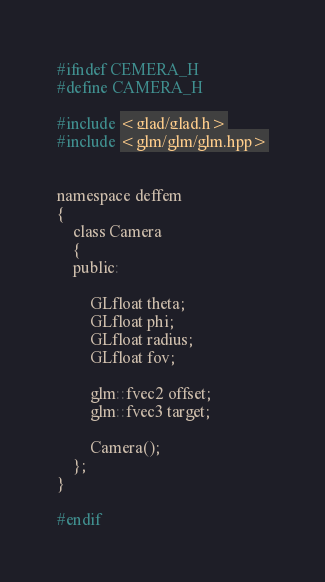Convert code to text. <code><loc_0><loc_0><loc_500><loc_500><_C_>#ifndef CEMERA_H
#define CAMERA_H

#include <glad/glad.h>
#include <glm/glm/glm.hpp>


namespace deffem
{
    class Camera
    {
    public:

        GLfloat theta;
        GLfloat phi;
        GLfloat radius;
        GLfloat fov;

        glm::fvec2 offset;
        glm::fvec3 target;

        Camera();
    };
}

#endif
</code> 